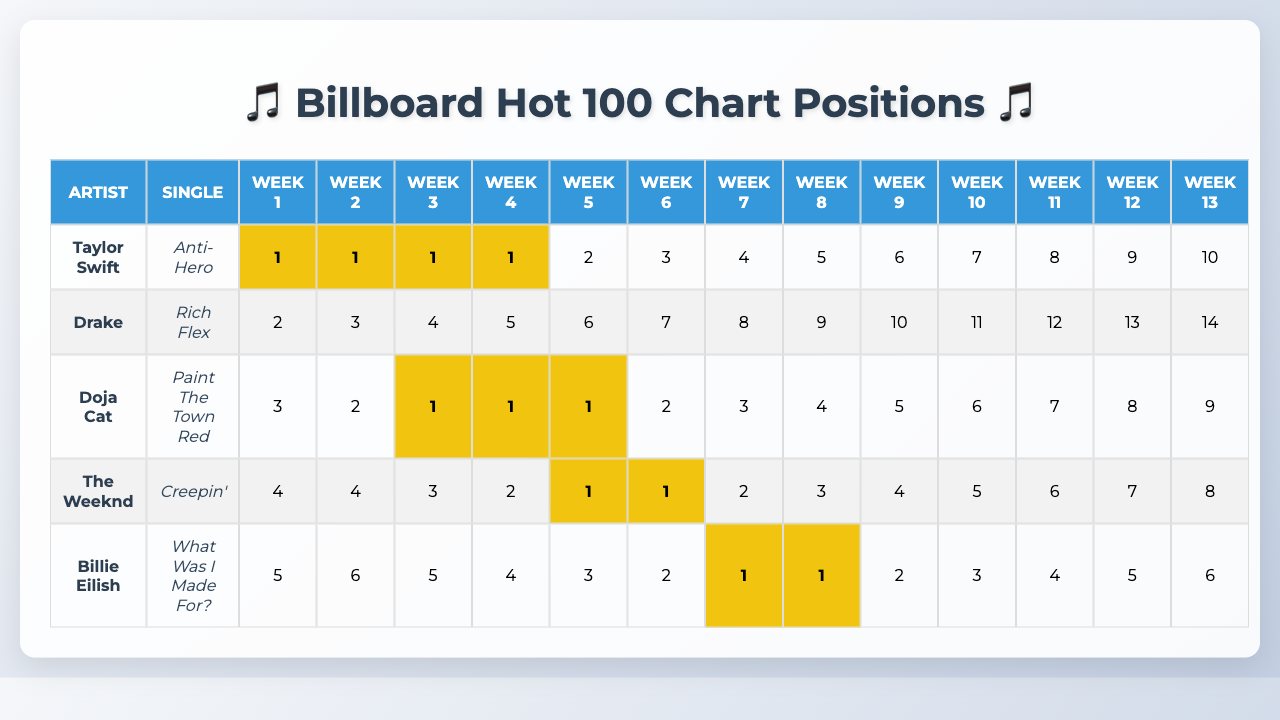What is the highest chart position achieved by Taylor Swift's single "Anti-Hero"? By checking the row corresponding to Taylor Swift and looking for the minimum value in her chart positions, we see that "Anti-Hero" reached position 1 in several weeks.
Answer: 1 Which single by Doja Cat had the best chart position in the last quarter? Looking at Doja Cat's row, the lowest position listed is 1, and it occurred in the 3rd, 4th, and 5th weeks.
Answer: Paint The Town Red How many weeks did "Creepin'" by The Weeknd remain in the top 5? Examining the chart positions for "Creepin'", we find that it was in the top 5 for the first 5 weeks.
Answer: 5 Did Billie Eilish’s single "What Was I Made For?" ever reach the top position? Analyzing the chart positions for "What Was I Made For?", the lowest position is 1, which means it did reach the top rank.
Answer: Yes What was the average chart position of Drake's single "Rich Flex"? Drake's chart positions are 2, 3, 4, 5, 6, 7, 8, 9, 10, 11, 12, 13, and 14. The average is calculated as the sum of positions divided by the number of weeks: (2 + 3 + 4 + 5 + 6 + 7 + 8 + 9 + 10 + 11 + 12 + 13 + 14) / 13 = 9.
Answer: 9 Which artist had the most consistent placement in the top three during the last quarter? Upon reviewing the chart positions, Taylor Swift and Doja Cat both spent the majority of the time within the top three; however, Taylor Swift had more weeks at position 1.
Answer: Taylor Swift How many singles reached number 1 for more than five weeks? Checking the chart positions, only "Anti-Hero" achieved position 1 for four weeks, and "What Was I Made For?" achieved it just for two weeks regarding the total number of weeks stated, so none reached it for more than five weeks.
Answer: 0 What was the position of The Weeknd's "Creepin'" in week 7? In the table, the chart position for "Creepin'" in week 7 is 2.
Answer: 2 How many artists had singles that reached position 1 at least once? By examining all the artists’ singles, "Anti-Hero," "Paint The Town Red," and "Creepin'" all reached number 1, meaning three artists achieved this rank.
Answer: 3 Which single had the most significant drop in chart position from week 1 to week 13? Analyzing the drops, "Anti-Hero" went from 1 to 10, a drop of 9 positions; "Rich Flex" dropped from 2 to 14, a drop of 12 positions; hence "Rich Flex" has the most significant drop.
Answer: Rich Flex 